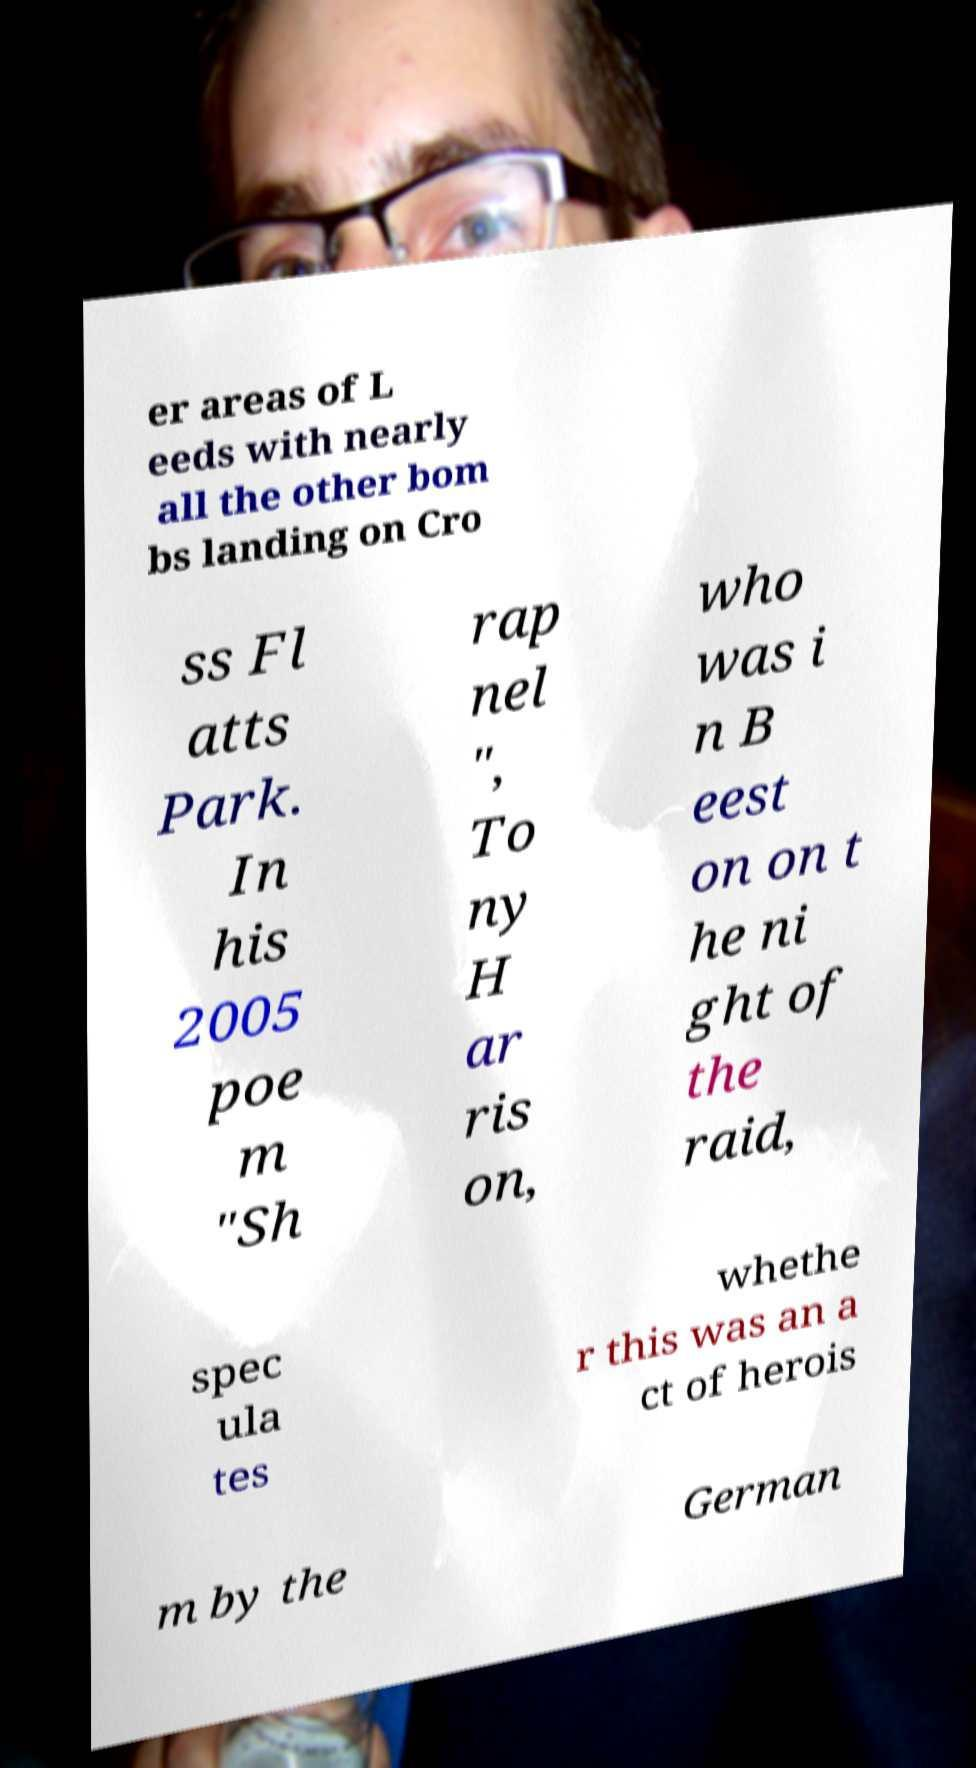Can you read and provide the text displayed in the image?This photo seems to have some interesting text. Can you extract and type it out for me? er areas of L eeds with nearly all the other bom bs landing on Cro ss Fl atts Park. In his 2005 poe m "Sh rap nel ", To ny H ar ris on, who was i n B eest on on t he ni ght of the raid, spec ula tes whethe r this was an a ct of herois m by the German 